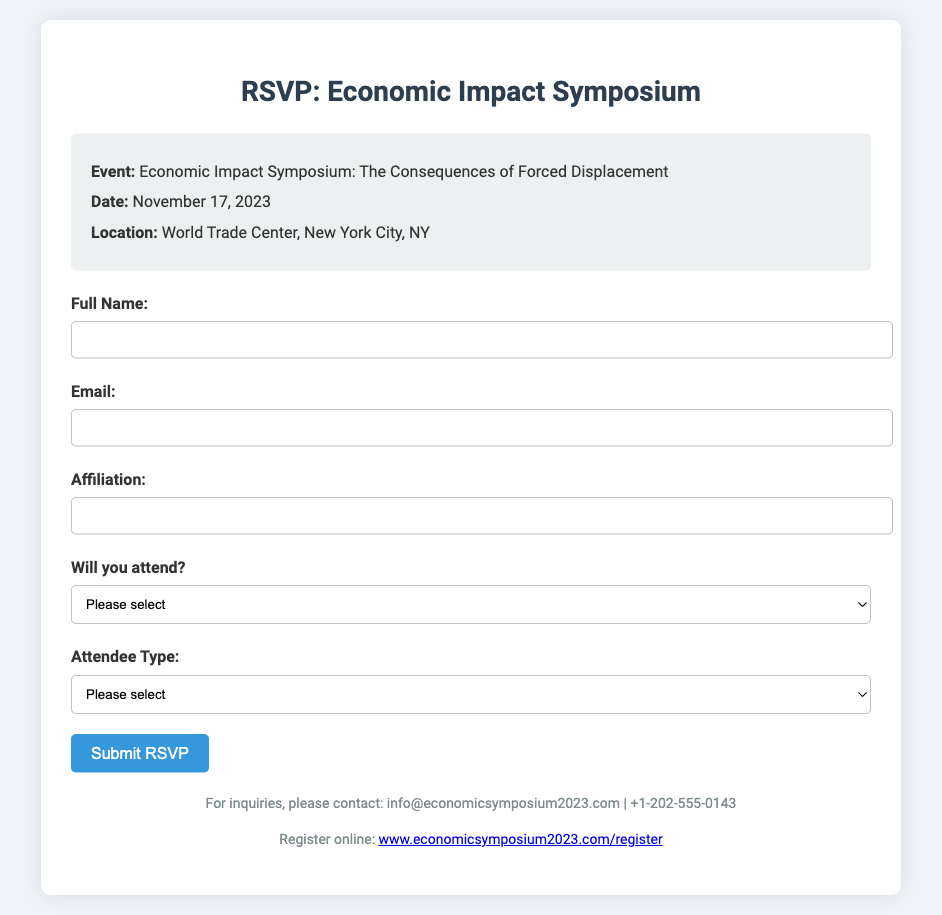what is the date of the symposium? The date of the symposium is clearly stated in the event details section, which is November 17, 2023.
Answer: November 17, 2023 where is the symposium located? The location of the symposium is mentioned in the document as the World Trade Center, New York City, NY.
Answer: World Trade Center, New York City, NY what are the two types of attendees? The document lists the types of attendees available for registration, which are Student and Professional.
Answer: Student, Professional what is the cost for professional attendees? The cost for professionals is specified in the attendee type section, which is $100.
Answer: $100 what is the email for inquiries? The email provided for inquiries is mentioned in the footer section of the document as info@economicsymposium2023.com.
Answer: info@economicsymposium2023.com how can one register for the symposium online? The document provides a link for online registration in the footer section, which is www.economicsymposium2023.com/register.
Answer: www.economicsymposium2023.com/register how many options are provided for attendance? The attendance section offers two options, which are 'Yes, I will attend' and 'No, I cannot attend.'
Answer: Two who is the target audience for this symposium? The symposium is designed primarily for those interested in the economic consequences of forced displacement, which may include economists, researchers, and professionals in the field.
Answer: Economists, researchers, professionals what is the primary focus of the symposium? The focus is indicated in the title of the event as the consequences of forced displacement.
Answer: Consequences of forced displacement 